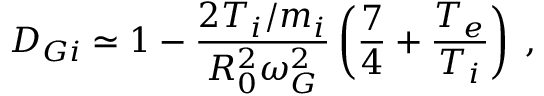Convert formula to latex. <formula><loc_0><loc_0><loc_500><loc_500>D _ { G i } \simeq 1 - \frac { 2 T _ { i } / m _ { i } } { R _ { 0 } ^ { 2 } \omega _ { G } ^ { 2 } } \left ( \frac { 7 } { 4 } + \frac { T _ { e } } { T _ { i } } \right ) \, ,</formula> 